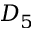Convert formula to latex. <formula><loc_0><loc_0><loc_500><loc_500>D _ { 5 }</formula> 